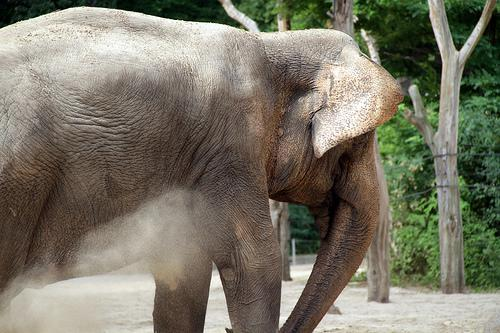Question: where was the photo taken?
Choices:
A. Near Tiger.
B. Near bear.
C. Near elephant.
D. Near zebra.
Answer with the letter. Answer: C Question: who has big ears?
Choices:
A. An elephant.
B. A lion.
C. A tiger.
D. A horse.
Answer with the letter. Answer: A Question: what is gray?
Choices:
A. Hyena.
B. Elephant.
C. Dog.
D. Cat.
Answer with the letter. Answer: B Question: what is green?
Choices:
A. Trees.
B. Grass.
C. Bushes.
D. Plants.
Answer with the letter. Answer: A Question: what has a long trunk?
Choices:
A. The elephant.
B. The tree.
C. The truck.
D. The car.
Answer with the letter. Answer: A Question: where is dirt?
Choices:
A. In the box.
B. In the bucket.
C. On the hill.
D. On the ground.
Answer with the letter. Answer: D 